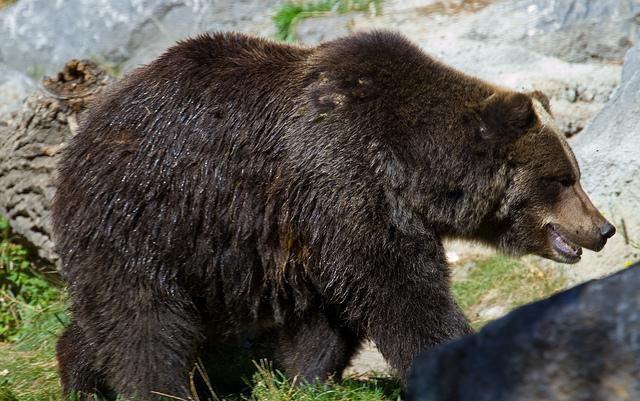How many people pictured are not part of the artwork?
Give a very brief answer. 0. 